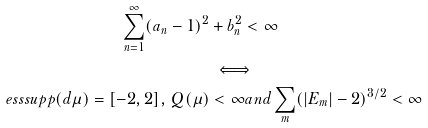Convert formula to latex. <formula><loc_0><loc_0><loc_500><loc_500>\sum _ { n = 1 } ^ { \infty } ( a _ { n } - 1 ) ^ { 2 } & + b _ { n } ^ { 2 } < \infty \\ & \iff \\ e s s s u p p ( d \mu ) = [ - 2 , 2 ] , \, Q ( \mu ) & < \infty a n d \sum _ { m } ( | E _ { m } | - 2 ) ^ { 3 / 2 } < \infty</formula> 